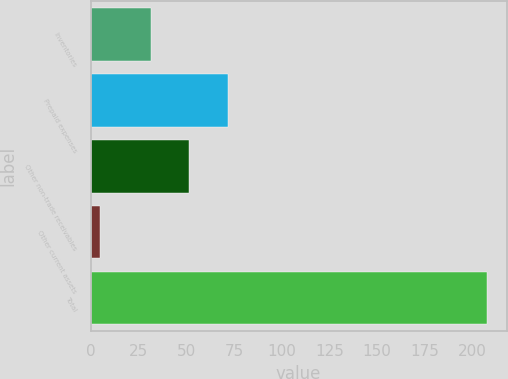Convert chart. <chart><loc_0><loc_0><loc_500><loc_500><bar_chart><fcel>Inventories<fcel>Prepaid expenses<fcel>Other non-trade receivables<fcel>Other current assets<fcel>Total<nl><fcel>31.3<fcel>71.78<fcel>51.54<fcel>5<fcel>207.4<nl></chart> 